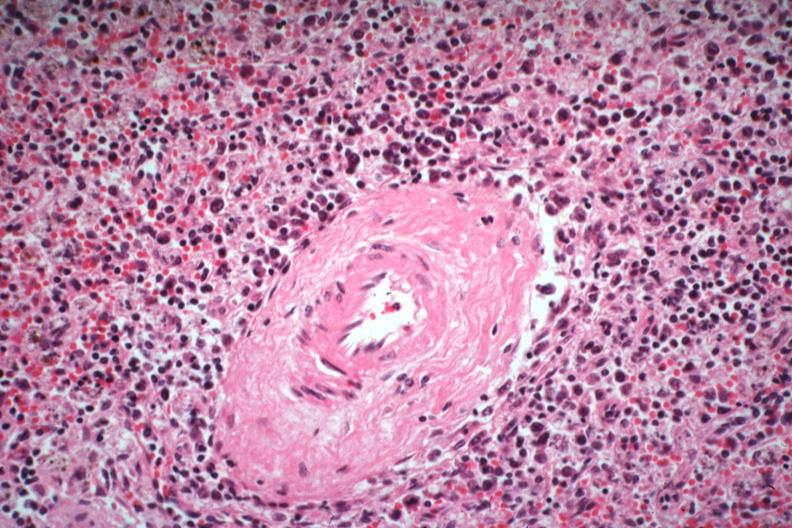s spleen present?
Answer the question using a single word or phrase. Yes 